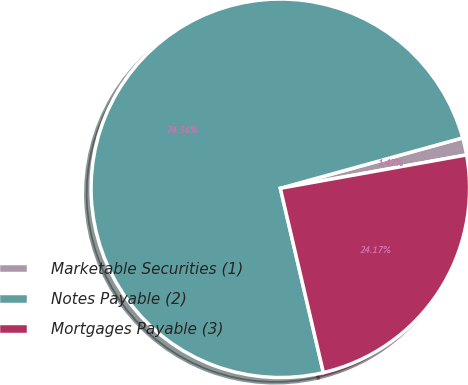Convert chart to OTSL. <chart><loc_0><loc_0><loc_500><loc_500><pie_chart><fcel>Marketable Securities (1)<fcel>Notes Payable (2)<fcel>Mortgages Payable (3)<nl><fcel>1.47%<fcel>74.37%<fcel>24.17%<nl></chart> 